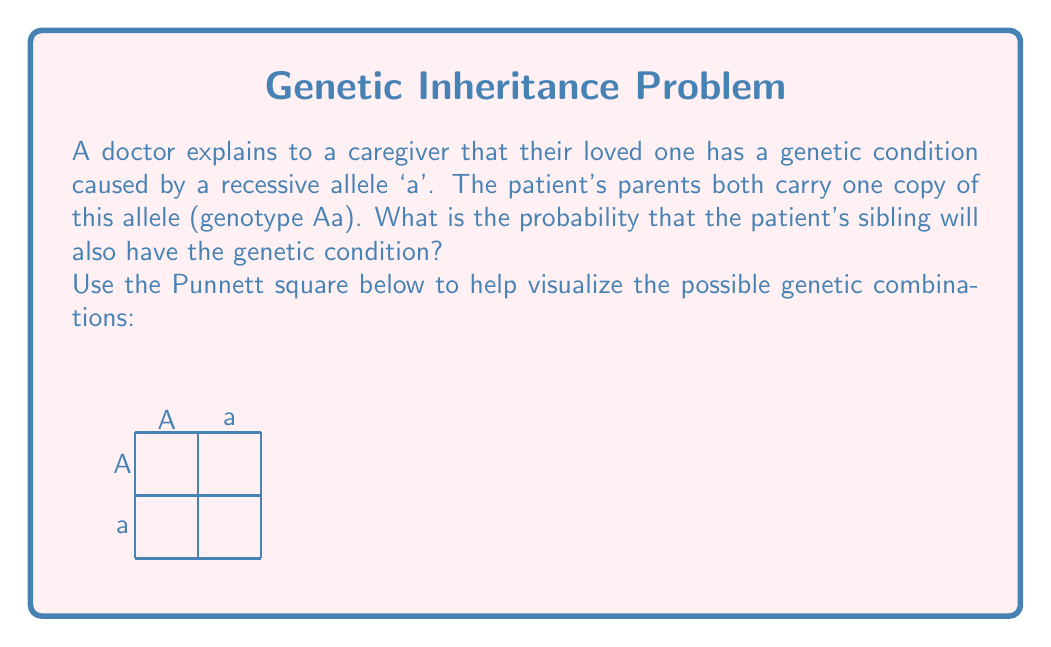Give your solution to this math problem. To solve this problem, we'll use a Punnett square and probability theory:

1) First, let's fill in the Punnett square:
   - The father's alleles (Aa) go along the top
   - The mother's alleles (Aa) go along the side

   The completed Punnett square looks like this:

   [asy]
   unitsize(1cm);
   draw((0,0)--(2,0)--(2,2)--(0,2)--cycle);
   draw((1,0)--(1,2));
   draw((0,1)--(2,1));
   label("A", (0.5,2.2));
   label("a", (1.5,2.2));
   label("A", (-0.2,1.5));
   label("a", (-0.2,0.5));
   label("AA", (0.5,1.5));
   label("Aa", (1.5,1.5));
   label("Aa", (0.5,0.5));
   label("aa", (1.5,0.5));
   [/asy]

2) The genetic condition is caused by the recessive allele 'a'. For an individual to have the condition, they must inherit 'a' from both parents (genotype aa).

3) From the Punnett square, we can see that only one out of the four possible outcomes results in the 'aa' genotype.

4) The probability of an event is calculated by dividing the number of favorable outcomes by the total number of possible outcomes:

   $$ P(\text{aa genotype}) = \frac{\text{Number of aa outcomes}}{\text{Total number of outcomes}} = \frac{1}{4} = 0.25 $$

5) Therefore, the probability that the patient's sibling will have the genetic condition is 0.25 or 25%.

This approach allows the caregiver to visualize and understand the inheritance pattern, which can be helpful in comprehending the holistic nature of the genetic condition and its impact on the family.
Answer: $\frac{1}{4}$ or 0.25 or 25% 